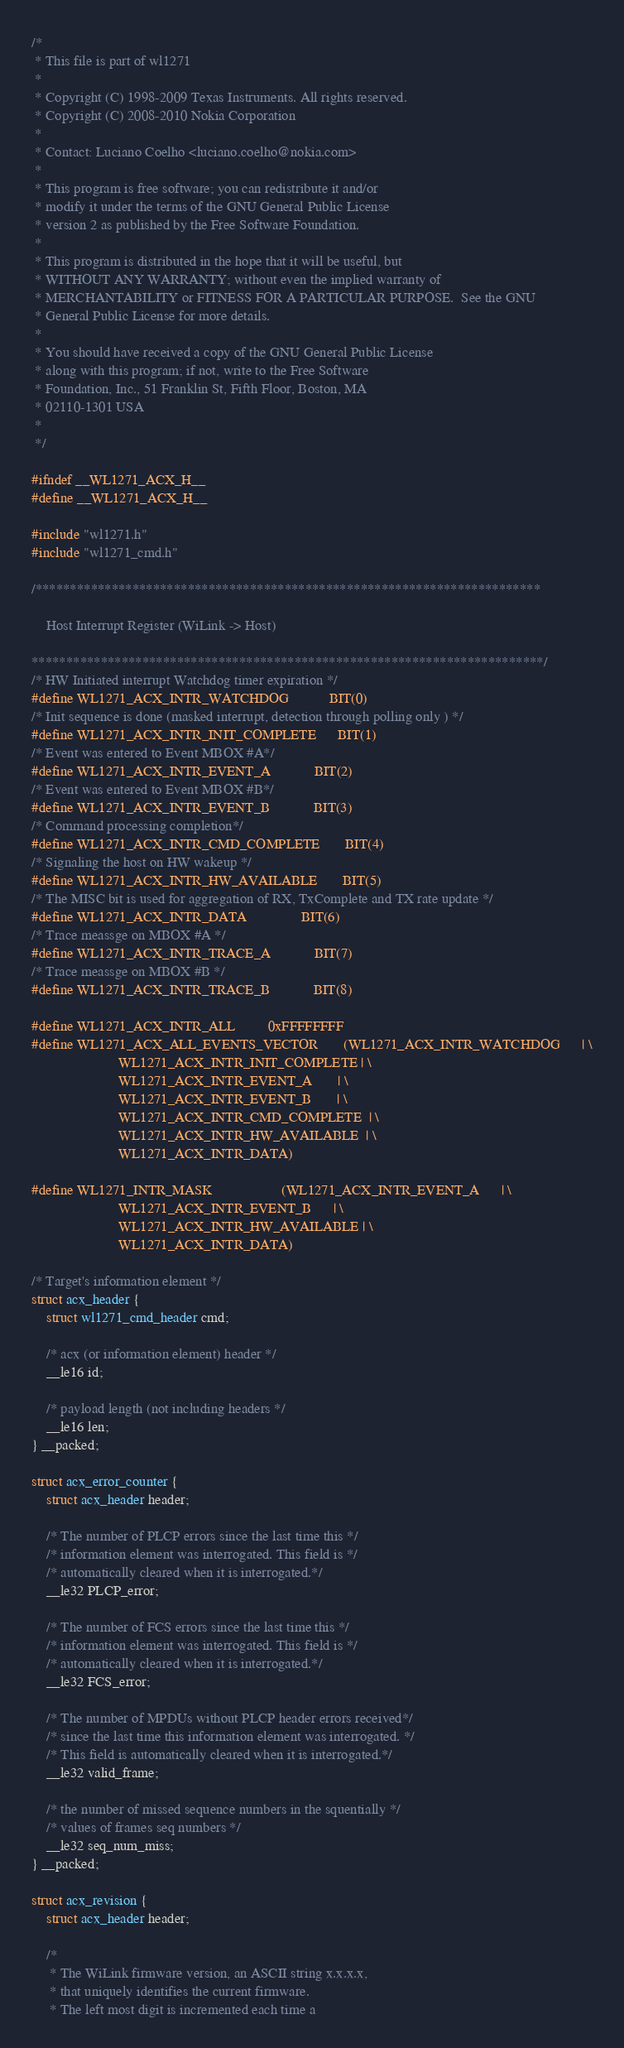Convert code to text. <code><loc_0><loc_0><loc_500><loc_500><_C_>/*
 * This file is part of wl1271
 *
 * Copyright (C) 1998-2009 Texas Instruments. All rights reserved.
 * Copyright (C) 2008-2010 Nokia Corporation
 *
 * Contact: Luciano Coelho <luciano.coelho@nokia.com>
 *
 * This program is free software; you can redistribute it and/or
 * modify it under the terms of the GNU General Public License
 * version 2 as published by the Free Software Foundation.
 *
 * This program is distributed in the hope that it will be useful, but
 * WITHOUT ANY WARRANTY; without even the implied warranty of
 * MERCHANTABILITY or FITNESS FOR A PARTICULAR PURPOSE.  See the GNU
 * General Public License for more details.
 *
 * You should have received a copy of the GNU General Public License
 * along with this program; if not, write to the Free Software
 * Foundation, Inc., 51 Franklin St, Fifth Floor, Boston, MA
 * 02110-1301 USA
 *
 */

#ifndef __WL1271_ACX_H__
#define __WL1271_ACX_H__

#include "wl1271.h"
#include "wl1271_cmd.h"

/*************************************************************************

    Host Interrupt Register (WiLink -> Host)

**************************************************************************/
/* HW Initiated interrupt Watchdog timer expiration */
#define WL1271_ACX_INTR_WATCHDOG           BIT(0)
/* Init sequence is done (masked interrupt, detection through polling only ) */
#define WL1271_ACX_INTR_INIT_COMPLETE      BIT(1)
/* Event was entered to Event MBOX #A*/
#define WL1271_ACX_INTR_EVENT_A            BIT(2)
/* Event was entered to Event MBOX #B*/
#define WL1271_ACX_INTR_EVENT_B            BIT(3)
/* Command processing completion*/
#define WL1271_ACX_INTR_CMD_COMPLETE       BIT(4)
/* Signaling the host on HW wakeup */
#define WL1271_ACX_INTR_HW_AVAILABLE       BIT(5)
/* The MISC bit is used for aggregation of RX, TxComplete and TX rate update */
#define WL1271_ACX_INTR_DATA               BIT(6)
/* Trace meassge on MBOX #A */
#define WL1271_ACX_INTR_TRACE_A            BIT(7)
/* Trace meassge on MBOX #B */
#define WL1271_ACX_INTR_TRACE_B            BIT(8)

#define WL1271_ACX_INTR_ALL		   0xFFFFFFFF
#define WL1271_ACX_ALL_EVENTS_VECTOR       (WL1271_ACX_INTR_WATCHDOG      | \
					    WL1271_ACX_INTR_INIT_COMPLETE | \
					    WL1271_ACX_INTR_EVENT_A       | \
					    WL1271_ACX_INTR_EVENT_B       | \
					    WL1271_ACX_INTR_CMD_COMPLETE  | \
					    WL1271_ACX_INTR_HW_AVAILABLE  | \
					    WL1271_ACX_INTR_DATA)

#define WL1271_INTR_MASK                   (WL1271_ACX_INTR_EVENT_A      | \
					    WL1271_ACX_INTR_EVENT_B      | \
					    WL1271_ACX_INTR_HW_AVAILABLE | \
					    WL1271_ACX_INTR_DATA)

/* Target's information element */
struct acx_header {
	struct wl1271_cmd_header cmd;

	/* acx (or information element) header */
	__le16 id;

	/* payload length (not including headers */
	__le16 len;
} __packed;

struct acx_error_counter {
	struct acx_header header;

	/* The number of PLCP errors since the last time this */
	/* information element was interrogated. This field is */
	/* automatically cleared when it is interrogated.*/
	__le32 PLCP_error;

	/* The number of FCS errors since the last time this */
	/* information element was interrogated. This field is */
	/* automatically cleared when it is interrogated.*/
	__le32 FCS_error;

	/* The number of MPDUs without PLCP header errors received*/
	/* since the last time this information element was interrogated. */
	/* This field is automatically cleared when it is interrogated.*/
	__le32 valid_frame;

	/* the number of missed sequence numbers in the squentially */
	/* values of frames seq numbers */
	__le32 seq_num_miss;
} __packed;

struct acx_revision {
	struct acx_header header;

	/*
	 * The WiLink firmware version, an ASCII string x.x.x.x,
	 * that uniquely identifies the current firmware.
	 * The left most digit is incremented each time a</code> 